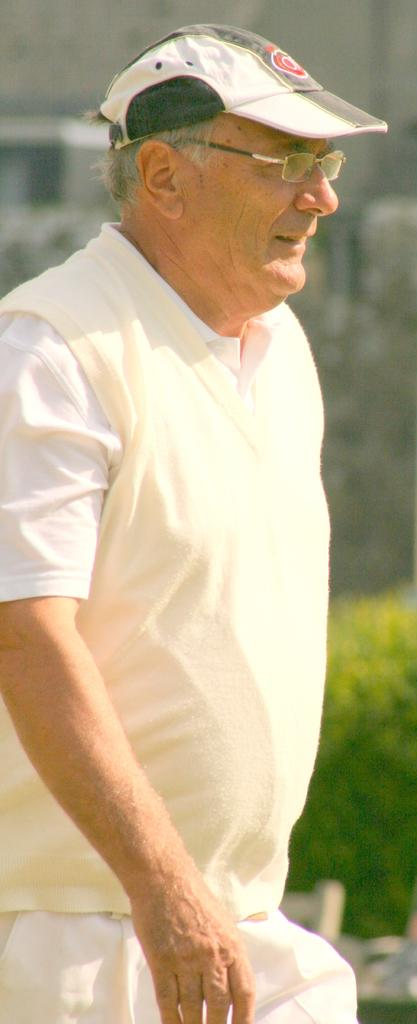Who is the main subject in the image? There is an old man in the image. What is the old man wearing on his head? The old man is wearing a hat. What type of eyewear is the old man wearing? The old man is wearing specs. What can be seen in the background of the image? There is a green color plant in the background of the image. What type of competition is the old man participating in within the image? There is no competition present in the image; it simply features an old man wearing a hat and specs, with a green color plant in the background. 